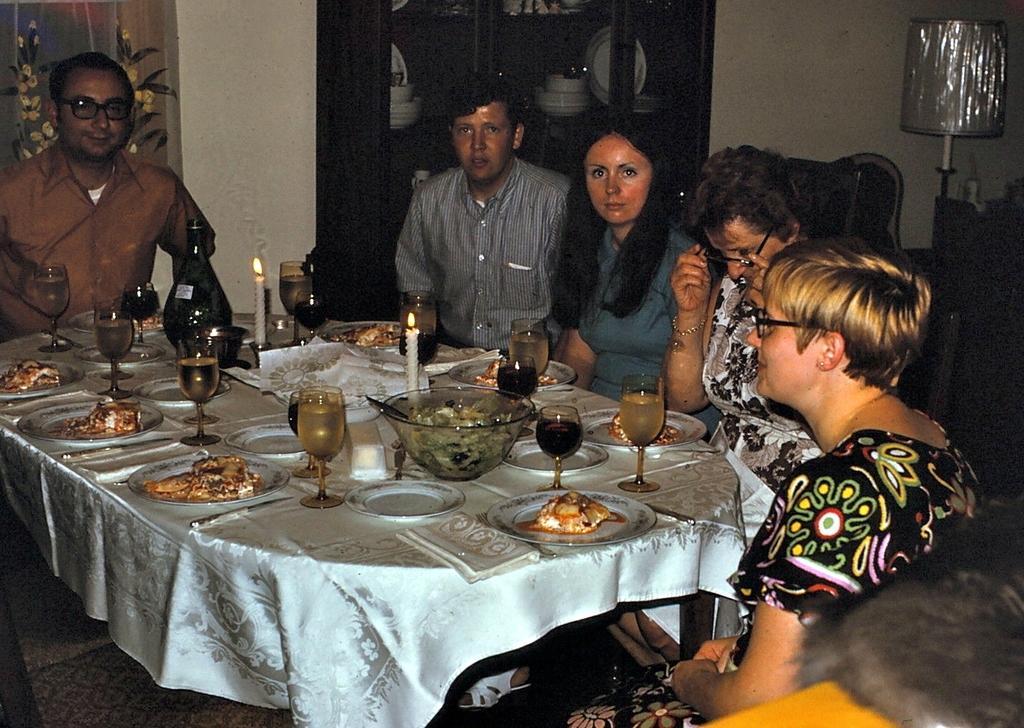In one or two sentences, can you explain what this image depicts? In this picture there are group of people sitting on the chair. There is a glass, bowl, spoon,candle, food in the plate. There is a cloth. There is a cupboard and few items in the cupboard There is a lamp at the background. 